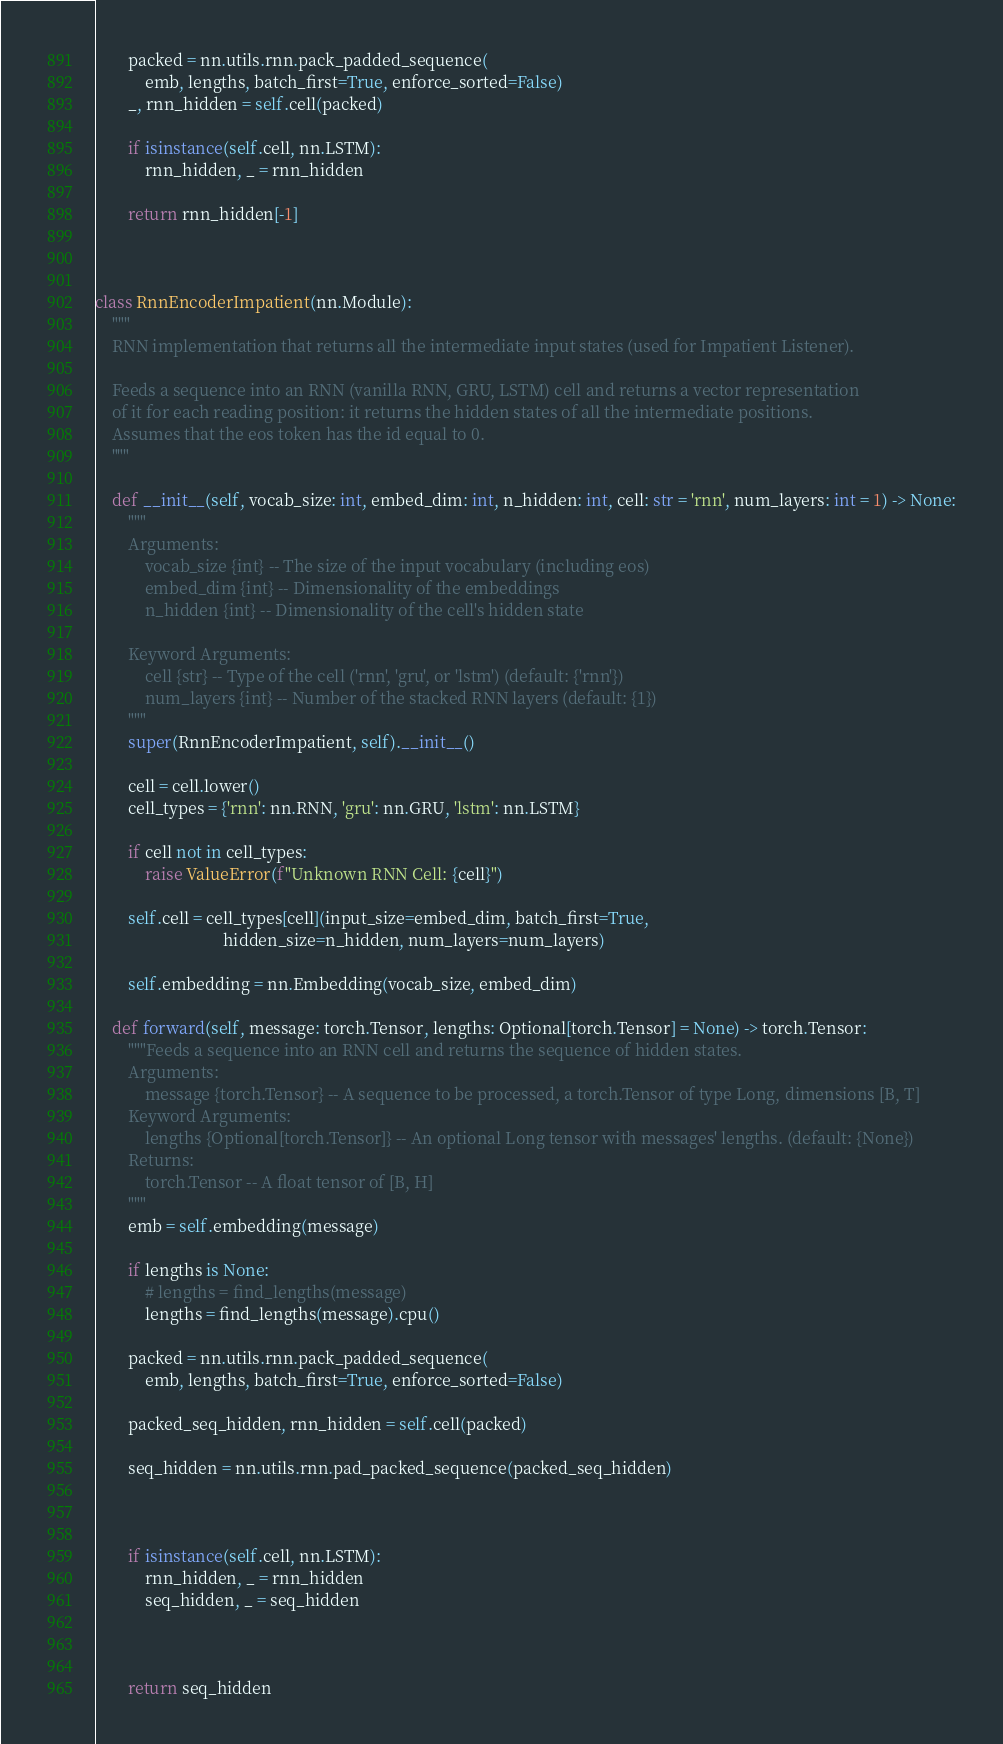Convert code to text. <code><loc_0><loc_0><loc_500><loc_500><_Python_>        packed = nn.utils.rnn.pack_padded_sequence(
            emb, lengths, batch_first=True, enforce_sorted=False)
        _, rnn_hidden = self.cell(packed)

        if isinstance(self.cell, nn.LSTM):
            rnn_hidden, _ = rnn_hidden

        return rnn_hidden[-1]



class RnnEncoderImpatient(nn.Module):
    """
    RNN implementation that returns all the intermediate input states (used for Impatient Listener).
    
    Feeds a sequence into an RNN (vanilla RNN, GRU, LSTM) cell and returns a vector representation
    of it for each reading position: it returns the hidden states of all the intermediate positions.
    Assumes that the eos token has the id equal to 0.
    """

    def __init__(self, vocab_size: int, embed_dim: int, n_hidden: int, cell: str = 'rnn', num_layers: int = 1) -> None:
        """
        Arguments:
            vocab_size {int} -- The size of the input vocabulary (including eos)
            embed_dim {int} -- Dimensionality of the embeddings
            n_hidden {int} -- Dimensionality of the cell's hidden state

        Keyword Arguments:
            cell {str} -- Type of the cell ('rnn', 'gru', or 'lstm') (default: {'rnn'})
            num_layers {int} -- Number of the stacked RNN layers (default: {1})
        """
        super(RnnEncoderImpatient, self).__init__()

        cell = cell.lower()
        cell_types = {'rnn': nn.RNN, 'gru': nn.GRU, 'lstm': nn.LSTM}

        if cell not in cell_types:
            raise ValueError(f"Unknown RNN Cell: {cell}")

        self.cell = cell_types[cell](input_size=embed_dim, batch_first=True,
                               hidden_size=n_hidden, num_layers=num_layers)

        self.embedding = nn.Embedding(vocab_size, embed_dim)

    def forward(self, message: torch.Tensor, lengths: Optional[torch.Tensor] = None) -> torch.Tensor:
        """Feeds a sequence into an RNN cell and returns the sequence of hidden states.
        Arguments:
            message {torch.Tensor} -- A sequence to be processed, a torch.Tensor of type Long, dimensions [B, T]
        Keyword Arguments:
            lengths {Optional[torch.Tensor]} -- An optional Long tensor with messages' lengths. (default: {None})
        Returns:
            torch.Tensor -- A float tensor of [B, H]
        """
        emb = self.embedding(message)

        if lengths is None:
            # lengths = find_lengths(message)
            lengths = find_lengths(message).cpu()

        packed = nn.utils.rnn.pack_padded_sequence(
            emb, lengths, batch_first=True, enforce_sorted=False)

        packed_seq_hidden, rnn_hidden = self.cell(packed)

        seq_hidden = nn.utils.rnn.pad_packed_sequence(packed_seq_hidden)



        if isinstance(self.cell, nn.LSTM):
            rnn_hidden, _ = rnn_hidden
            seq_hidden, _ = seq_hidden



        return seq_hidden
</code> 